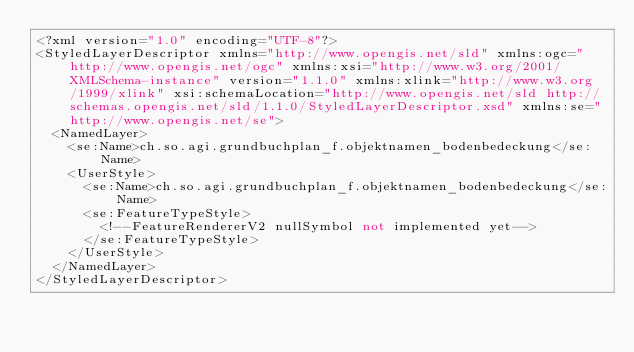Convert code to text. <code><loc_0><loc_0><loc_500><loc_500><_Scheme_><?xml version="1.0" encoding="UTF-8"?>
<StyledLayerDescriptor xmlns="http://www.opengis.net/sld" xmlns:ogc="http://www.opengis.net/ogc" xmlns:xsi="http://www.w3.org/2001/XMLSchema-instance" version="1.1.0" xmlns:xlink="http://www.w3.org/1999/xlink" xsi:schemaLocation="http://www.opengis.net/sld http://schemas.opengis.net/sld/1.1.0/StyledLayerDescriptor.xsd" xmlns:se="http://www.opengis.net/se">
  <NamedLayer>
    <se:Name>ch.so.agi.grundbuchplan_f.objektnamen_bodenbedeckung</se:Name>
    <UserStyle>
      <se:Name>ch.so.agi.grundbuchplan_f.objektnamen_bodenbedeckung</se:Name>
      <se:FeatureTypeStyle>
        <!--FeatureRendererV2 nullSymbol not implemented yet-->
      </se:FeatureTypeStyle>
    </UserStyle>
  </NamedLayer>
</StyledLayerDescriptor>
</code> 